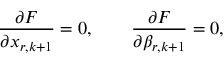Convert formula to latex. <formula><loc_0><loc_0><loc_500><loc_500>\frac { \partial F } { \partial x _ { r , k + 1 } } = 0 , \quad \frac { \partial F } { \partial \beta _ { r , k + 1 } } = 0 ,</formula> 